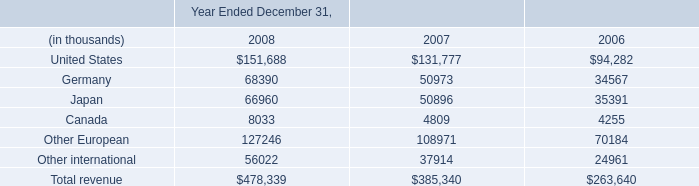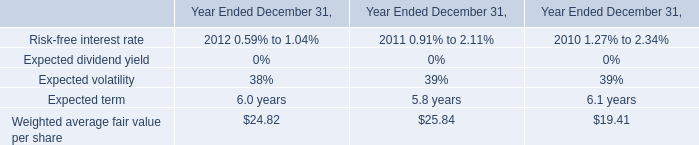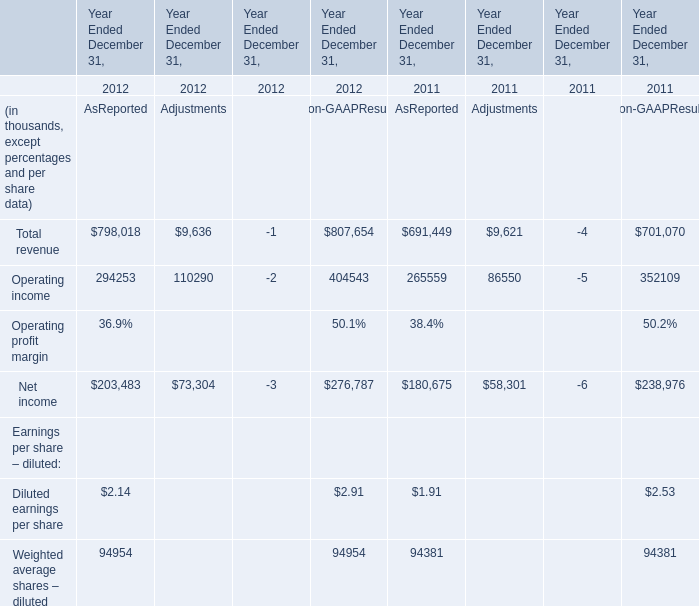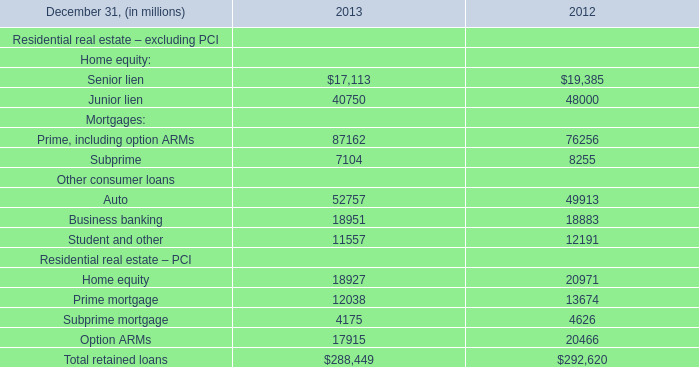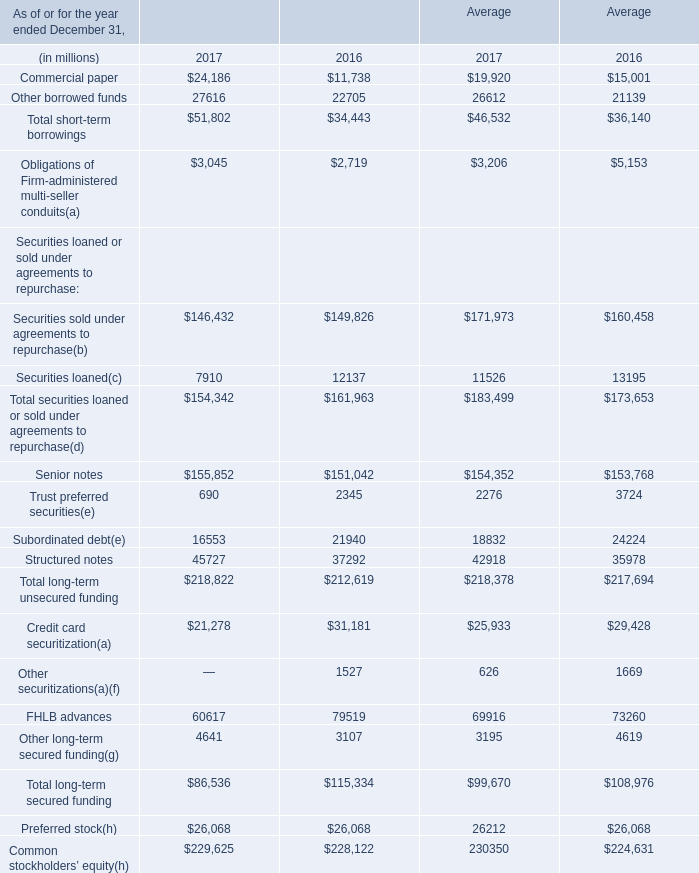what was the average future minimum lease payments under noncancellable operating leases for office space from 2009 to 2013 in millions . 
Computations: (((((8.8 + 6.6) + 3.0) + 1.8) + 1.1) / 4)
Answer: 5.325. 